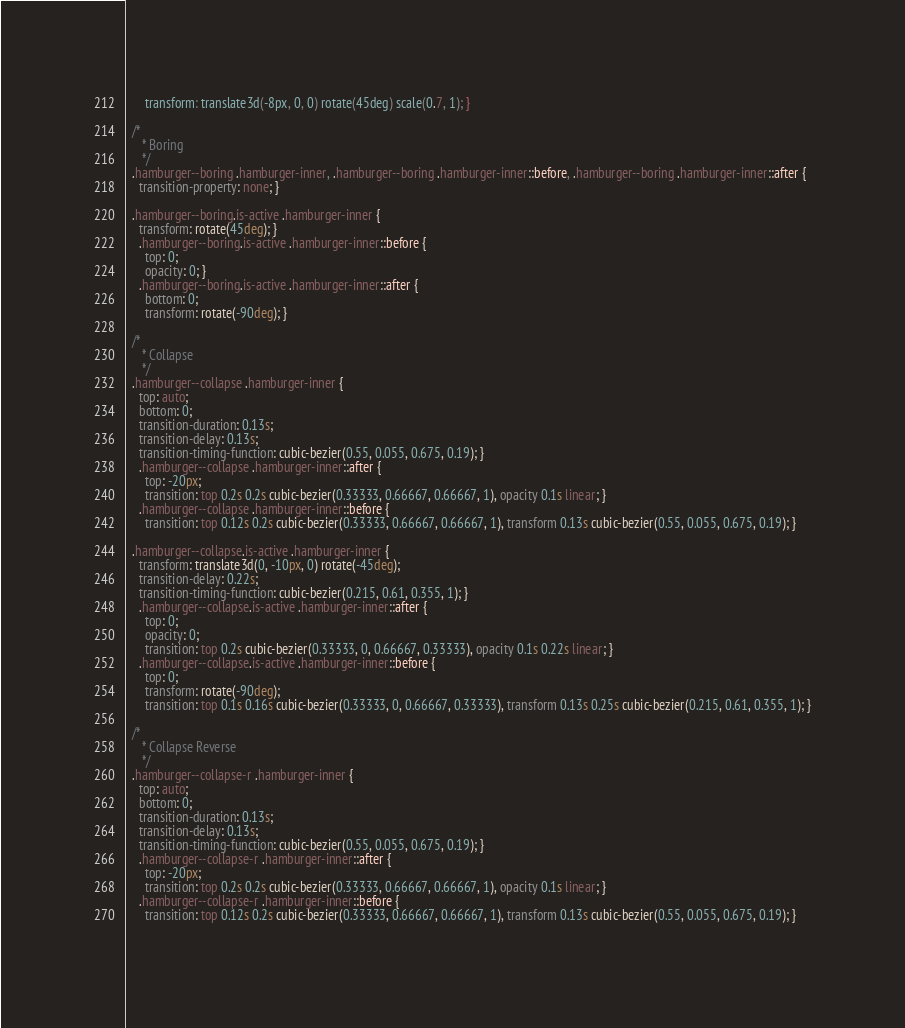<code> <loc_0><loc_0><loc_500><loc_500><_CSS_>      transform: translate3d(-8px, 0, 0) rotate(45deg) scale(0.7, 1); }
  
  /*
     * Boring
     */
  .hamburger--boring .hamburger-inner, .hamburger--boring .hamburger-inner::before, .hamburger--boring .hamburger-inner::after {
    transition-property: none; }
  
  .hamburger--boring.is-active .hamburger-inner {
    transform: rotate(45deg); }
    .hamburger--boring.is-active .hamburger-inner::before {
      top: 0;
      opacity: 0; }
    .hamburger--boring.is-active .hamburger-inner::after {
      bottom: 0;
      transform: rotate(-90deg); }
  
  /*
     * Collapse
     */
  .hamburger--collapse .hamburger-inner {
    top: auto;
    bottom: 0;
    transition-duration: 0.13s;
    transition-delay: 0.13s;
    transition-timing-function: cubic-bezier(0.55, 0.055, 0.675, 0.19); }
    .hamburger--collapse .hamburger-inner::after {
      top: -20px;
      transition: top 0.2s 0.2s cubic-bezier(0.33333, 0.66667, 0.66667, 1), opacity 0.1s linear; }
    .hamburger--collapse .hamburger-inner::before {
      transition: top 0.12s 0.2s cubic-bezier(0.33333, 0.66667, 0.66667, 1), transform 0.13s cubic-bezier(0.55, 0.055, 0.675, 0.19); }
  
  .hamburger--collapse.is-active .hamburger-inner {
    transform: translate3d(0, -10px, 0) rotate(-45deg);
    transition-delay: 0.22s;
    transition-timing-function: cubic-bezier(0.215, 0.61, 0.355, 1); }
    .hamburger--collapse.is-active .hamburger-inner::after {
      top: 0;
      opacity: 0;
      transition: top 0.2s cubic-bezier(0.33333, 0, 0.66667, 0.33333), opacity 0.1s 0.22s linear; }
    .hamburger--collapse.is-active .hamburger-inner::before {
      top: 0;
      transform: rotate(-90deg);
      transition: top 0.1s 0.16s cubic-bezier(0.33333, 0, 0.66667, 0.33333), transform 0.13s 0.25s cubic-bezier(0.215, 0.61, 0.355, 1); }
  
  /*
     * Collapse Reverse
     */
  .hamburger--collapse-r .hamburger-inner {
    top: auto;
    bottom: 0;
    transition-duration: 0.13s;
    transition-delay: 0.13s;
    transition-timing-function: cubic-bezier(0.55, 0.055, 0.675, 0.19); }
    .hamburger--collapse-r .hamburger-inner::after {
      top: -20px;
      transition: top 0.2s 0.2s cubic-bezier(0.33333, 0.66667, 0.66667, 1), opacity 0.1s linear; }
    .hamburger--collapse-r .hamburger-inner::before {
      transition: top 0.12s 0.2s cubic-bezier(0.33333, 0.66667, 0.66667, 1), transform 0.13s cubic-bezier(0.55, 0.055, 0.675, 0.19); }
  </code> 